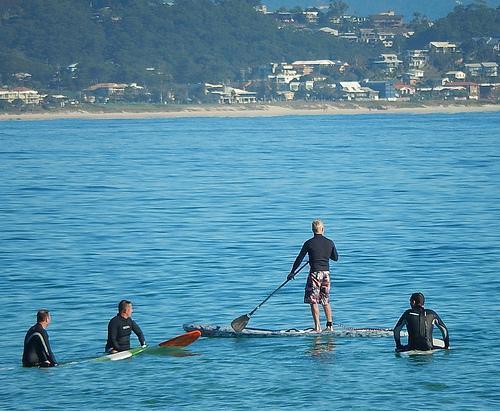How many person are inside the water?
Give a very brief answer. 3. How many person stand there?
Give a very brief answer. 1. How many people are to the left of the person standing?
Give a very brief answer. 2. 